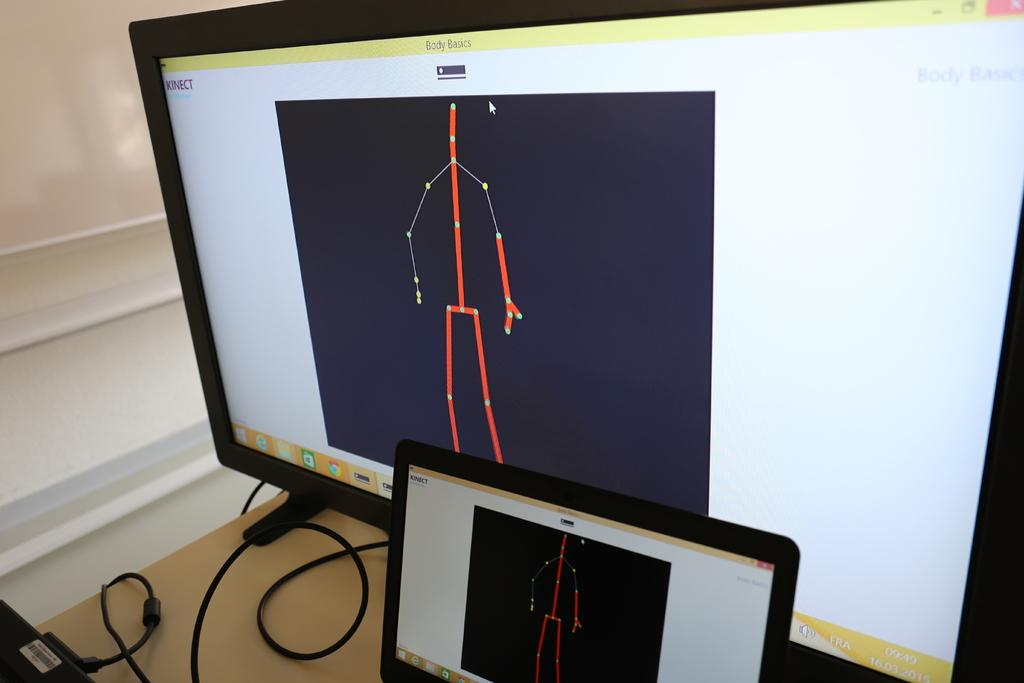Provide a one-sentence caption for the provided image. A computer monitor with a phone in front both with a stick figure in red with dots on the body.. 